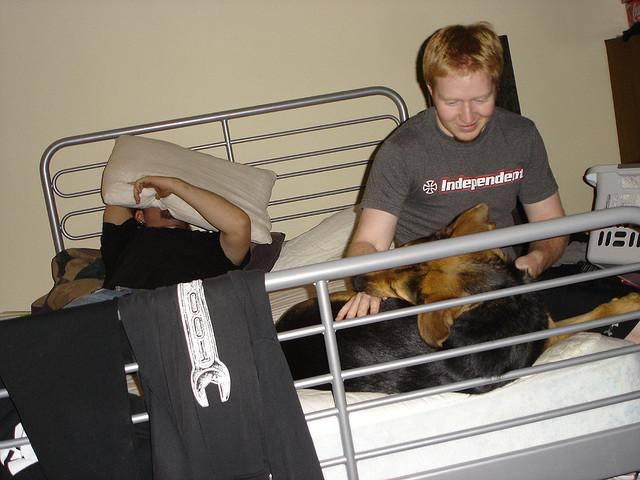How many people are in the picture?
Quick response, please. 2. Is there a laundry basket in the picture?
Write a very short answer. Yes. What type of bed frame does he have?
Concise answer only. Metal. 